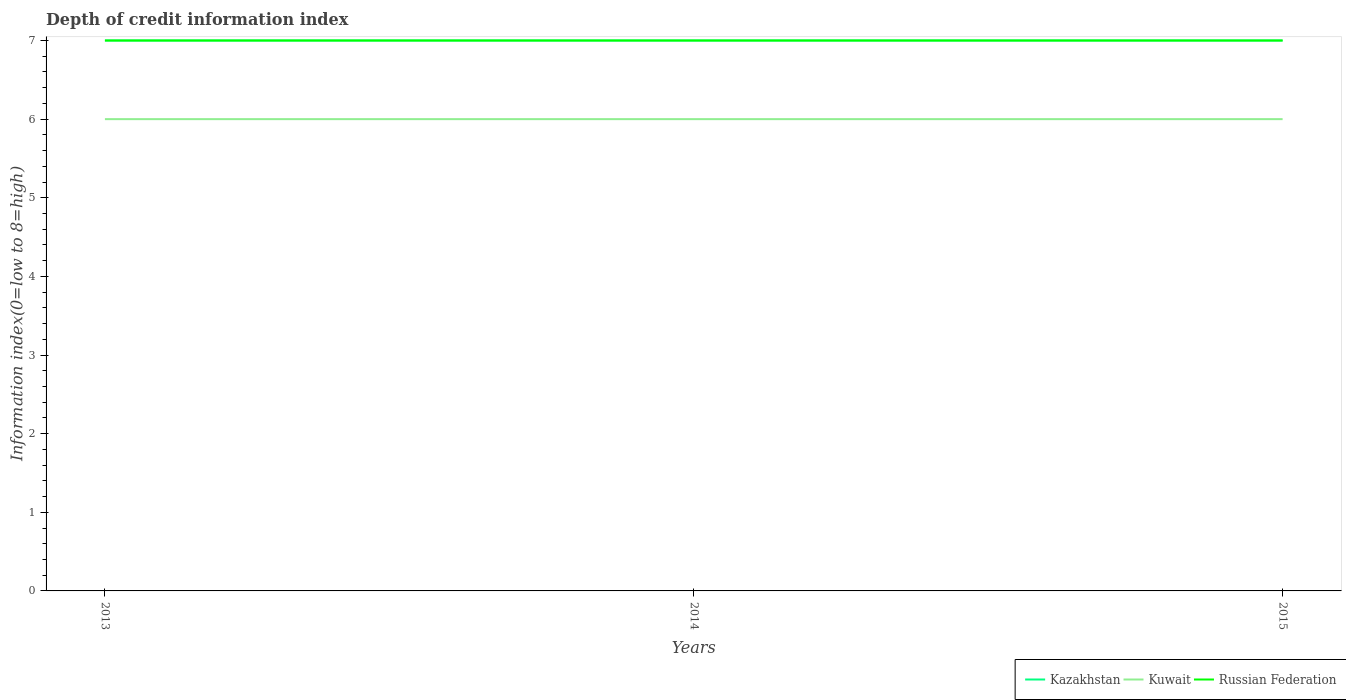How many different coloured lines are there?
Your answer should be compact. 3. Across all years, what is the maximum information index in Russian Federation?
Your answer should be very brief. 7. What is the total information index in Russian Federation in the graph?
Offer a very short reply. 0. What is the difference between the highest and the second highest information index in Kazakhstan?
Keep it short and to the point. 0. What is the difference between the highest and the lowest information index in Russian Federation?
Provide a short and direct response. 0. Is the information index in Kuwait strictly greater than the information index in Russian Federation over the years?
Keep it short and to the point. Yes. How many lines are there?
Offer a terse response. 3. How many years are there in the graph?
Provide a succinct answer. 3. What is the difference between two consecutive major ticks on the Y-axis?
Provide a short and direct response. 1. Are the values on the major ticks of Y-axis written in scientific E-notation?
Offer a very short reply. No. Does the graph contain any zero values?
Ensure brevity in your answer.  No. Where does the legend appear in the graph?
Your answer should be compact. Bottom right. How many legend labels are there?
Keep it short and to the point. 3. What is the title of the graph?
Give a very brief answer. Depth of credit information index. Does "Guyana" appear as one of the legend labels in the graph?
Ensure brevity in your answer.  No. What is the label or title of the X-axis?
Provide a short and direct response. Years. What is the label or title of the Y-axis?
Provide a succinct answer. Information index(0=low to 8=high). What is the Information index(0=low to 8=high) of Kuwait in 2013?
Offer a very short reply. 6. What is the Information index(0=low to 8=high) in Russian Federation in 2013?
Your answer should be compact. 7. What is the Information index(0=low to 8=high) in Kuwait in 2014?
Keep it short and to the point. 6. What is the Information index(0=low to 8=high) in Kazakhstan in 2015?
Offer a very short reply. 7. Across all years, what is the maximum Information index(0=low to 8=high) of Kazakhstan?
Make the answer very short. 7. Across all years, what is the maximum Information index(0=low to 8=high) in Kuwait?
Ensure brevity in your answer.  6. Across all years, what is the maximum Information index(0=low to 8=high) in Russian Federation?
Offer a terse response. 7. Across all years, what is the minimum Information index(0=low to 8=high) in Kazakhstan?
Keep it short and to the point. 7. Across all years, what is the minimum Information index(0=low to 8=high) of Russian Federation?
Provide a succinct answer. 7. What is the total Information index(0=low to 8=high) in Kazakhstan in the graph?
Offer a very short reply. 21. What is the total Information index(0=low to 8=high) in Russian Federation in the graph?
Give a very brief answer. 21. What is the difference between the Information index(0=low to 8=high) of Kuwait in 2013 and that in 2014?
Make the answer very short. 0. What is the difference between the Information index(0=low to 8=high) of Kazakhstan in 2013 and that in 2015?
Provide a succinct answer. 0. What is the difference between the Information index(0=low to 8=high) of Russian Federation in 2013 and that in 2015?
Give a very brief answer. 0. What is the difference between the Information index(0=low to 8=high) of Kazakhstan in 2014 and that in 2015?
Make the answer very short. 0. What is the difference between the Information index(0=low to 8=high) of Kuwait in 2013 and the Information index(0=low to 8=high) of Russian Federation in 2014?
Provide a succinct answer. -1. What is the difference between the Information index(0=low to 8=high) in Kuwait in 2013 and the Information index(0=low to 8=high) in Russian Federation in 2015?
Ensure brevity in your answer.  -1. What is the difference between the Information index(0=low to 8=high) of Kazakhstan in 2014 and the Information index(0=low to 8=high) of Russian Federation in 2015?
Your response must be concise. 0. What is the difference between the Information index(0=low to 8=high) of Kuwait in 2014 and the Information index(0=low to 8=high) of Russian Federation in 2015?
Provide a short and direct response. -1. What is the average Information index(0=low to 8=high) of Russian Federation per year?
Keep it short and to the point. 7. In the year 2013, what is the difference between the Information index(0=low to 8=high) of Kazakhstan and Information index(0=low to 8=high) of Russian Federation?
Your answer should be very brief. 0. In the year 2014, what is the difference between the Information index(0=low to 8=high) in Kuwait and Information index(0=low to 8=high) in Russian Federation?
Offer a terse response. -1. In the year 2015, what is the difference between the Information index(0=low to 8=high) in Kazakhstan and Information index(0=low to 8=high) in Kuwait?
Your response must be concise. 1. In the year 2015, what is the difference between the Information index(0=low to 8=high) of Kazakhstan and Information index(0=low to 8=high) of Russian Federation?
Your answer should be very brief. 0. What is the ratio of the Information index(0=low to 8=high) of Kazakhstan in 2013 to that in 2014?
Provide a short and direct response. 1. What is the ratio of the Information index(0=low to 8=high) of Kuwait in 2013 to that in 2014?
Provide a short and direct response. 1. What is the ratio of the Information index(0=low to 8=high) of Russian Federation in 2013 to that in 2014?
Offer a very short reply. 1. What is the ratio of the Information index(0=low to 8=high) in Kazakhstan in 2013 to that in 2015?
Your answer should be compact. 1. What is the ratio of the Information index(0=low to 8=high) in Russian Federation in 2013 to that in 2015?
Ensure brevity in your answer.  1. What is the ratio of the Information index(0=low to 8=high) of Kazakhstan in 2014 to that in 2015?
Your answer should be compact. 1. What is the ratio of the Information index(0=low to 8=high) of Russian Federation in 2014 to that in 2015?
Your answer should be very brief. 1. What is the difference between the highest and the second highest Information index(0=low to 8=high) of Kuwait?
Provide a succinct answer. 0. What is the difference between the highest and the second highest Information index(0=low to 8=high) of Russian Federation?
Offer a terse response. 0. What is the difference between the highest and the lowest Information index(0=low to 8=high) of Kazakhstan?
Ensure brevity in your answer.  0. 